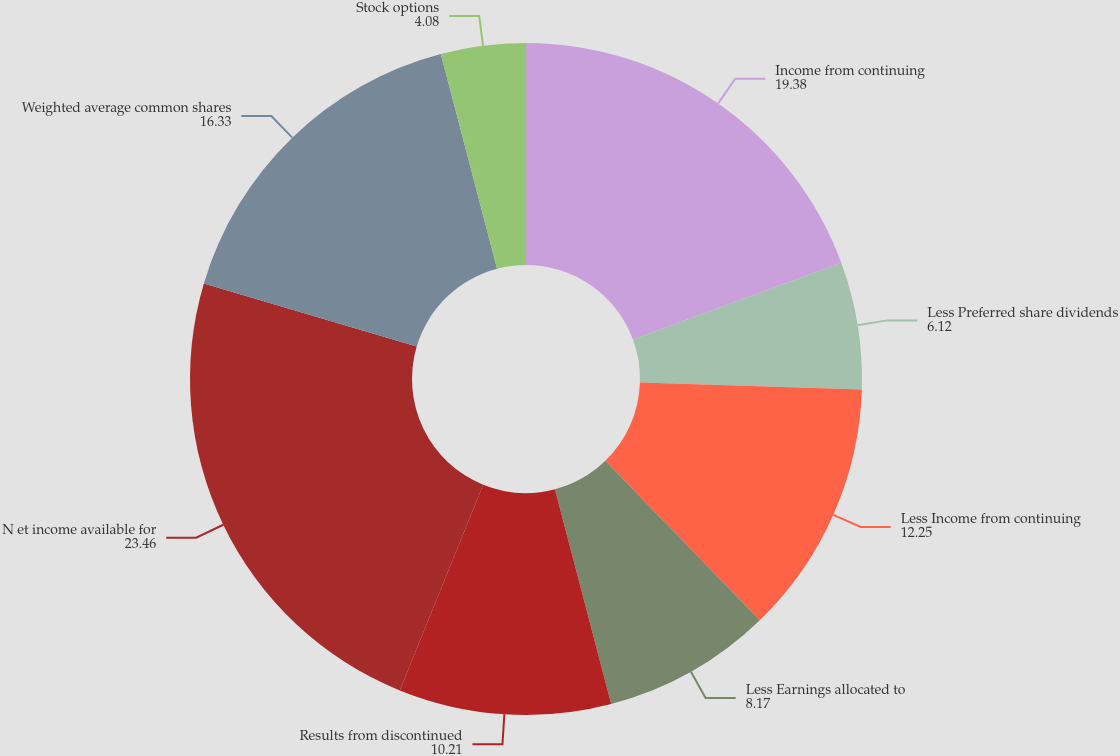Convert chart to OTSL. <chart><loc_0><loc_0><loc_500><loc_500><pie_chart><fcel>Income from continuing<fcel>Less Preferred share dividends<fcel>Less Income from continuing<fcel>Less Earnings allocated to<fcel>Results from discontinued<fcel>N et income available for<fcel>Weighted average common shares<fcel>Stock options<nl><fcel>19.38%<fcel>6.12%<fcel>12.25%<fcel>8.17%<fcel>10.21%<fcel>23.46%<fcel>16.33%<fcel>4.08%<nl></chart> 